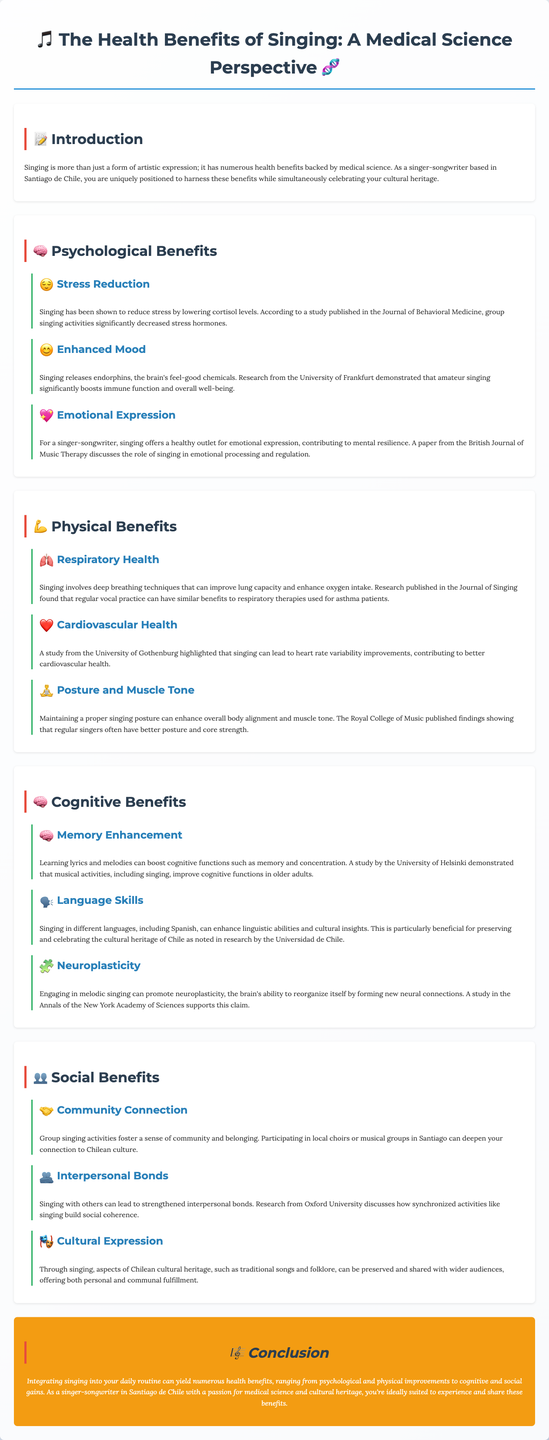What are the psychological benefits of singing? The section outlines three psychological benefits: stress reduction, enhanced mood, and emotional expression.
Answer: Stress reduction, enhanced mood, emotional expression What is one physiological improvement associated with singing? The document mentions improved lung capacity and enhanced oxygen intake as a physiological benefit.
Answer: Improved lung capacity How does singing affect cognitive functions in older adults? Research indicated that musical activities, including singing, boost cognitive functions such as memory and concentration in older adults.
Answer: Boost memory and concentration Which study found a connection between singing and heart rate variability? The study from the University of Gothenburg highlighted the relationship between singing and heart rate variability.
Answer: University of Gothenburg What is one social benefit of group singing activities? The text states that group singing activities foster a sense of community and belonging.
Answer: Sense of community and belonging How do singing and language skills relate? The document states that singing in different languages enhances linguistic abilities and cultural insights.
Answer: Enhances linguistic abilities What is a unique aspect of singing mentioned in the cultural benefits section? The section emphasizes the preservation and sharing of Chilean cultural heritage through singing.
Answer: Preservation of Chilean cultural heritage Which journal published findings about singing's effects on emotional processing? The findings discussed in the context of emotional processing were published in the British Journal of Music Therapy.
Answer: British Journal of Music Therapy What conclusion is drawn regarding integrating singing into daily routines? The conclusion suggests that integrating singing into daily routines can yield numerous health benefits.
Answer: Numerous health benefits 